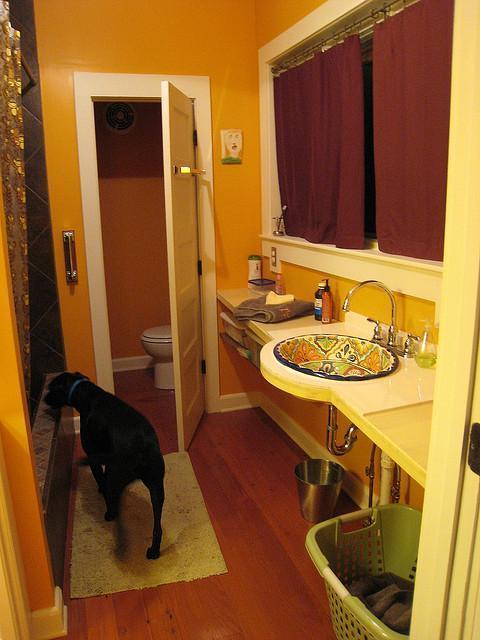How many sinks are visible?
Give a very brief answer. 1. 